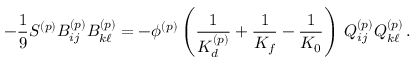<formula> <loc_0><loc_0><loc_500><loc_500>- \frac { 1 } { 9 } S ^ { ( p ) } B _ { i j } ^ { ( p ) } B _ { k \ell } ^ { ( p ) } = - \phi ^ { ( p ) } \left ( \frac { 1 } { K _ { d } ^ { ( p ) } } + \frac { 1 } { K _ { f } } - \frac { 1 } { K _ { 0 } } \right ) \, Q _ { i j } ^ { ( p ) } Q _ { k \ell } ^ { ( p ) } \, .</formula> 